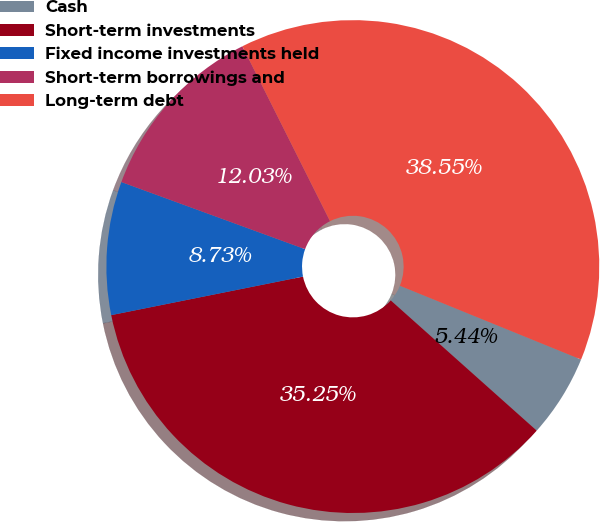Convert chart. <chart><loc_0><loc_0><loc_500><loc_500><pie_chart><fcel>Cash<fcel>Short-term investments<fcel>Fixed income investments held<fcel>Short-term borrowings and<fcel>Long-term debt<nl><fcel>5.44%<fcel>35.25%<fcel>8.73%<fcel>12.03%<fcel>38.55%<nl></chart> 